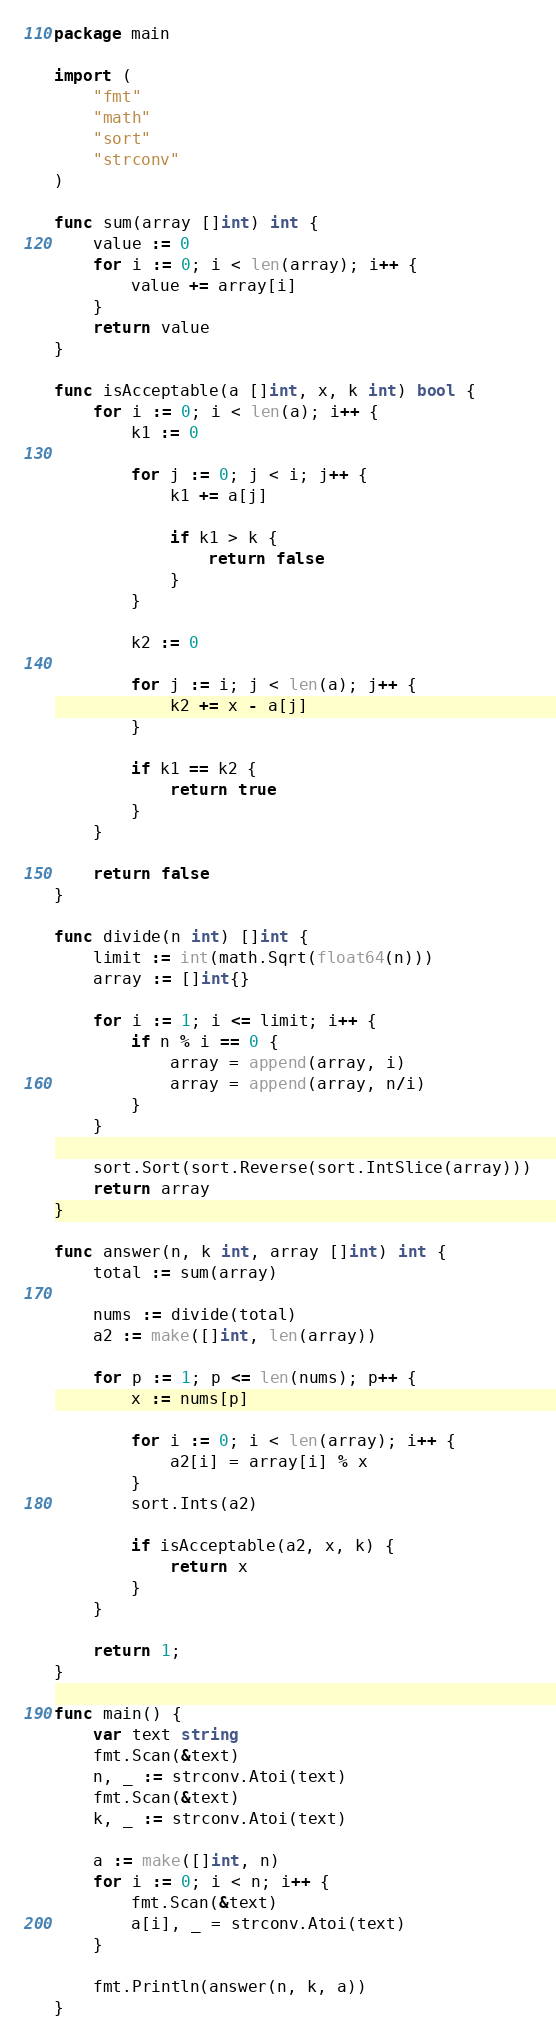Convert code to text. <code><loc_0><loc_0><loc_500><loc_500><_Go_>package main

import (
	"fmt"
	"math"
	"sort"
	"strconv"
)

func sum(array []int) int {
	value := 0
	for i := 0; i < len(array); i++ {
		value += array[i]
	}
	return value
}

func isAcceptable(a []int, x, k int) bool {
	for i := 0; i < len(a); i++ {
		k1 := 0

		for j := 0; j < i; j++ {
			k1 += a[j]

			if k1 > k {
				return false
			}
		}

		k2 := 0

		for j := i; j < len(a); j++ {
			k2 += x - a[j]
		}

		if k1 == k2 {
			return true
		}
	}

	return false
}

func divide(n int) []int {
	limit := int(math.Sqrt(float64(n)))
	array := []int{}

	for i := 1; i <= limit; i++ {
		if n % i == 0 {
			array = append(array, i)
			array = append(array, n/i)
		}
	}

	sort.Sort(sort.Reverse(sort.IntSlice(array)))
	return array
}

func answer(n, k int, array []int) int {
	total := sum(array)

	nums := divide(total)
	a2 := make([]int, len(array))

	for p := 1; p <= len(nums); p++ {
		x := nums[p]

		for i := 0; i < len(array); i++ {
			a2[i] = array[i] % x
		}
		sort.Ints(a2)

		if isAcceptable(a2, x, k) {
			return x
		}
	}

	return 1;
}

func main() {
	var text string
	fmt.Scan(&text)
	n, _ := strconv.Atoi(text)
	fmt.Scan(&text)
	k, _ := strconv.Atoi(text)

	a := make([]int, n)
	for i := 0; i < n; i++ {
		fmt.Scan(&text)
		a[i], _ = strconv.Atoi(text)
	}

	fmt.Println(answer(n, k, a))
}
</code> 